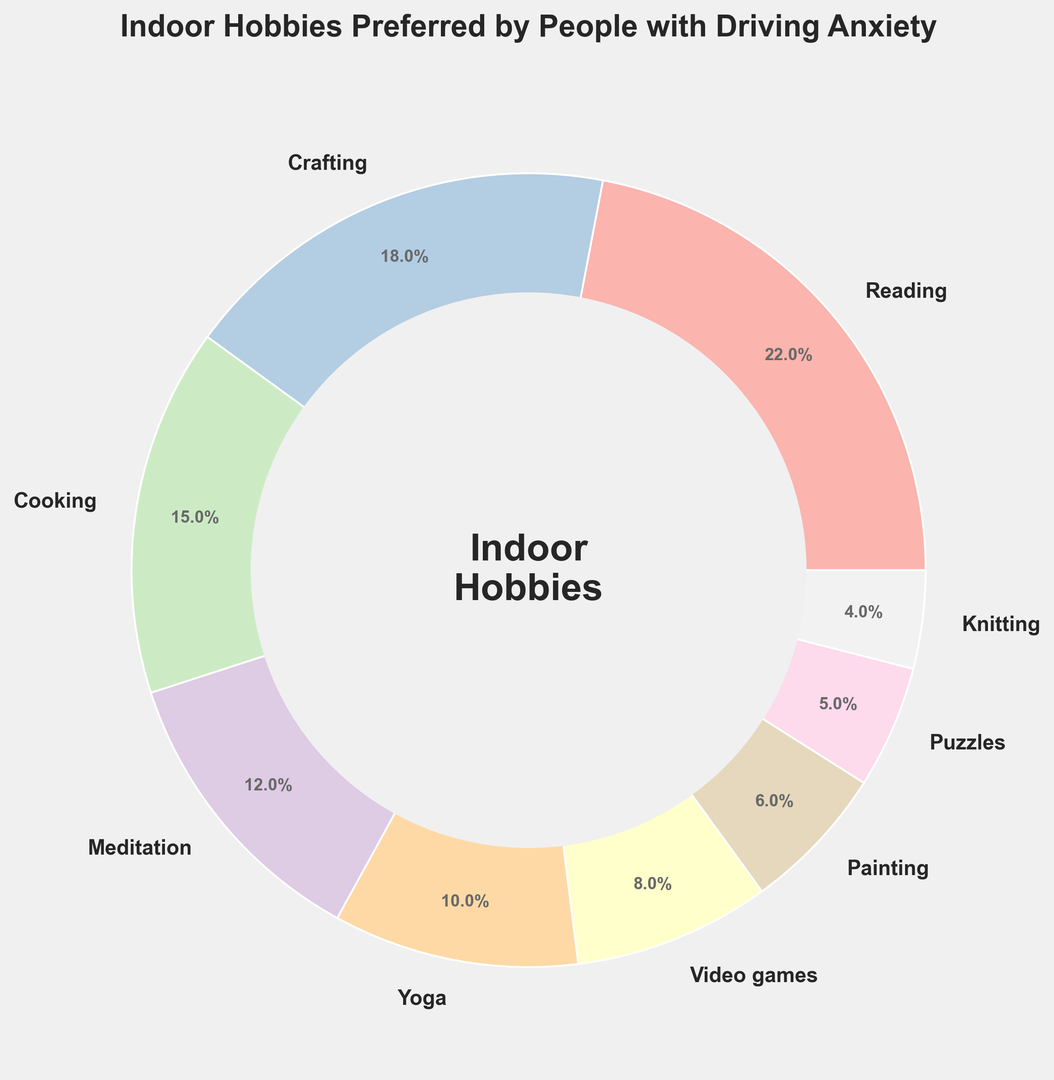What is the most preferred hobby by people with driving anxiety? Looking at the figure, the largest section of the ring chart represents the most preferred hobby. The chart indicates that Reading occupies the largest portion with 22%.
Answer: Reading Which has a higher percentage, Meditation or Video games? By comparing the two sections of the ring chart, Meditation is 12% and Video games is 8%. Therefore, Meditation has a higher percentage.
Answer: Meditation What is the combined percentage of Cooking and Yoga? To find the combined percentage, add the percentages of Cooking (15%) and Yoga (10%). Therefore, 15% + 10% = 25%.
Answer: 25% Which hobbies have a lower percentage than Painting? On the ring chart, Painting is shown at 6%. Comparing this to the other sections reveals that Puzzles (5%) and Knitting (4%) have lower percentages than Painting.
Answer: Puzzles and Knitting What is the difference in percentage between the most and least preferred hobbies? The chart shows the most preferred hobby, Reading, at 22% and the least preferred hobby, Knitting, at 4%. The difference is therefore 22% - 4% = 18%.
Answer: 18% Which section is larger, Crafting or Cooking? By looking at the chart, Crafting is shown at 18% and Cooking at 15%. Crafting is larger than Cooking.
Answer: Crafting What is the total percentage of hobbies that have more than 10% preference? The hobbies with more than 10% preference are Reading (22%), Crafting (18%), Cooking (15%), Meditation (12%), and Yoga (10%). Summing up these percentages: 22% + 18% + 15% + 12% + 10% = 77%.
Answer: 77% Is the Video games section closer in size to the Puzzles section or the Yoga section? Video games are shown at 8%, Puzzles at 5%, and Yoga at 10% on the chart. The difference between Video games and Puzzles is 8% - 5% = 3%, and the difference between Video games and Yoga is 10% - 8% = 2%. Therefore, the Video games section is closer in size to the Yoga section.
Answer: Yoga How many hobbies have a percentage greater than or equal to 10%? From the chart, the hobbies with a percentage greater than or equal to 10% are Reading (22%), Crafting (18%), Cooking (15%), Meditation (12%), and Yoga (10%). This makes a total of 5 hobbies.
Answer: 5 